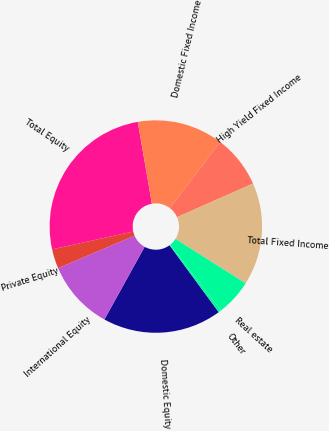Convert chart. <chart><loc_0><loc_0><loc_500><loc_500><pie_chart><fcel>Domestic Equity<fcel>International Equity<fcel>Private Equity<fcel>Total Equity<fcel>Domestic Fixed Income<fcel>High Yield Fixed Income<fcel>Total Fixed Income<fcel>Real estate<fcel>Other<nl><fcel>18.13%<fcel>10.55%<fcel>2.96%<fcel>25.72%<fcel>13.08%<fcel>8.02%<fcel>15.61%<fcel>5.49%<fcel>0.44%<nl></chart> 